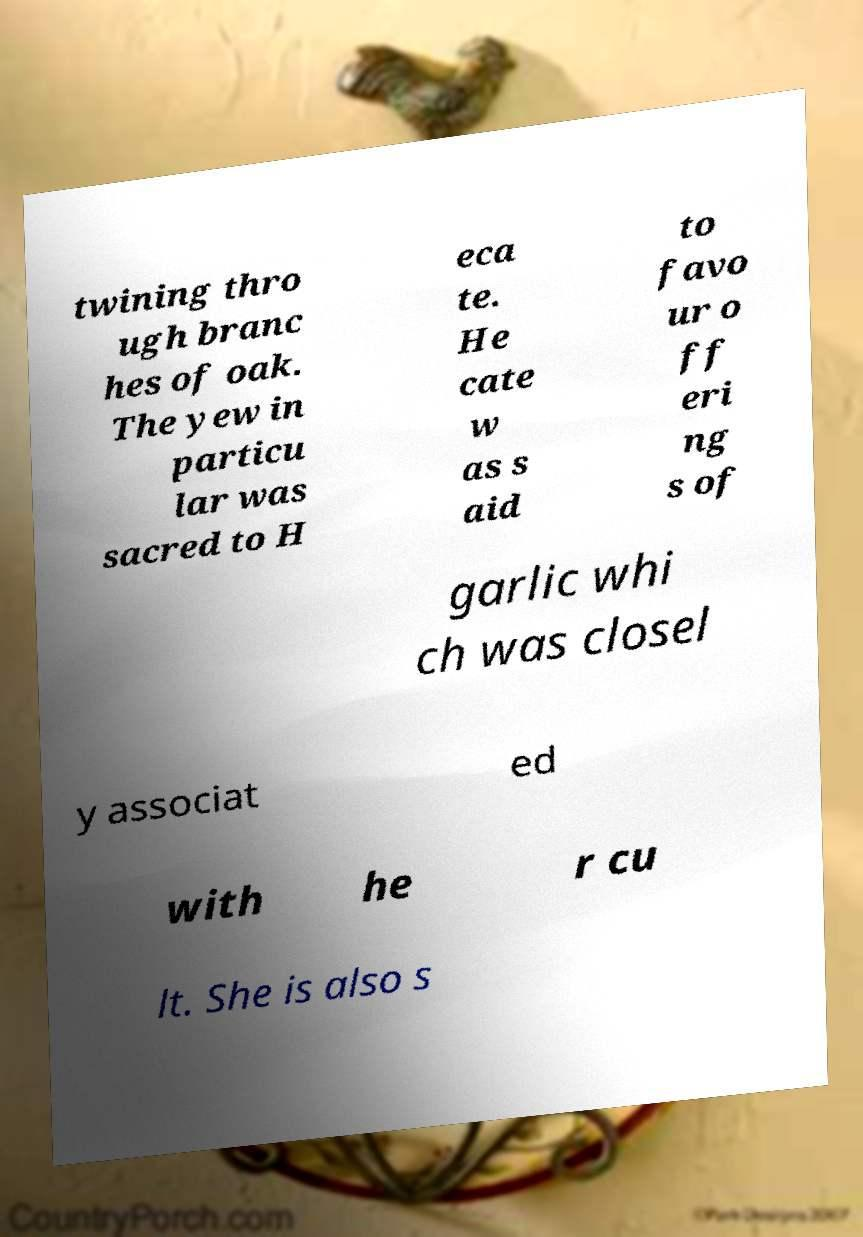There's text embedded in this image that I need extracted. Can you transcribe it verbatim? twining thro ugh branc hes of oak. The yew in particu lar was sacred to H eca te. He cate w as s aid to favo ur o ff eri ng s of garlic whi ch was closel y associat ed with he r cu lt. She is also s 